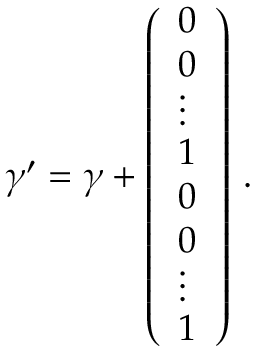Convert formula to latex. <formula><loc_0><loc_0><loc_500><loc_500>\gamma ^ { \prime } = \gamma + \left ( \begin{array} { l } { 0 } \\ { 0 } \\ { \vdots } \\ { 1 } \\ { 0 } \\ { 0 } \\ { \vdots } \\ { 1 } \end{array} \right ) \, .</formula> 